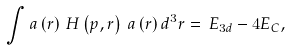<formula> <loc_0><loc_0><loc_500><loc_500>\int a \left ( r \right ) \, H \left ( p , r \right ) \, a \left ( r \right ) d ^ { 3 } r = \, E _ { 3 d } - 4 E _ { C } ,</formula> 